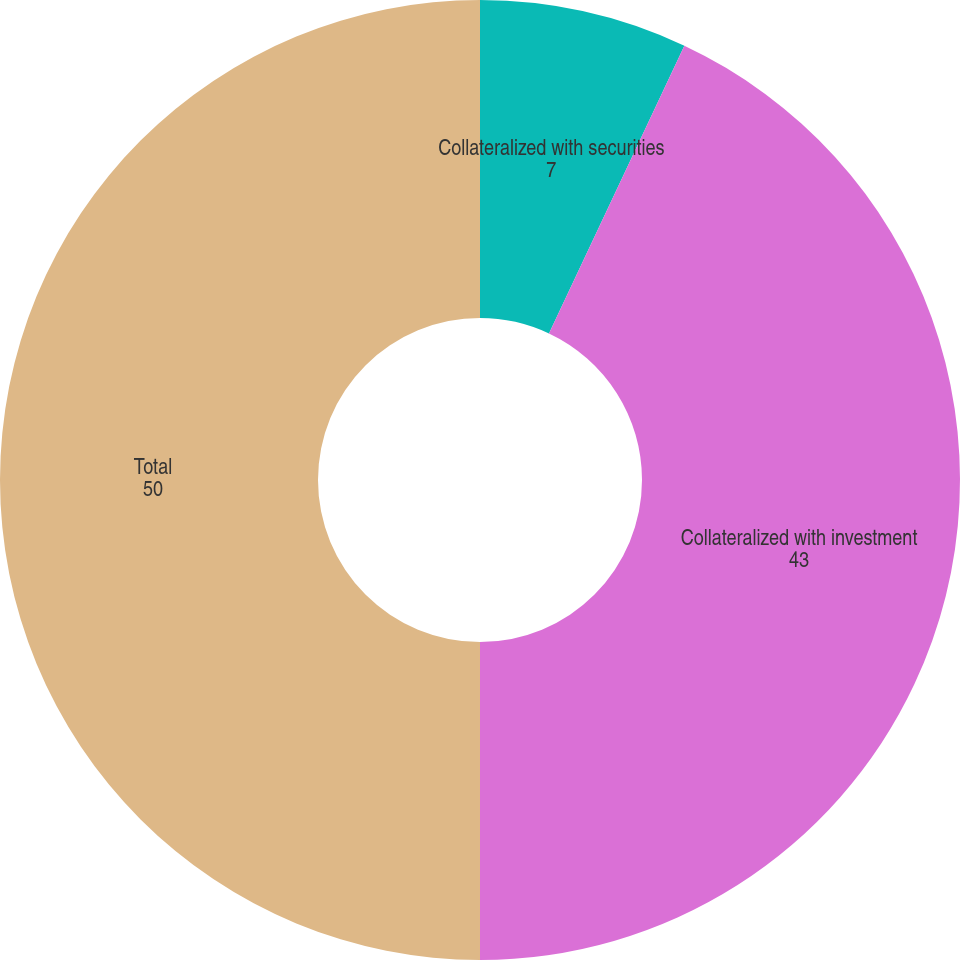Convert chart to OTSL. <chart><loc_0><loc_0><loc_500><loc_500><pie_chart><fcel>Collateralized with securities<fcel>Collateralized with investment<fcel>Total<nl><fcel>7.0%<fcel>43.0%<fcel>50.0%<nl></chart> 